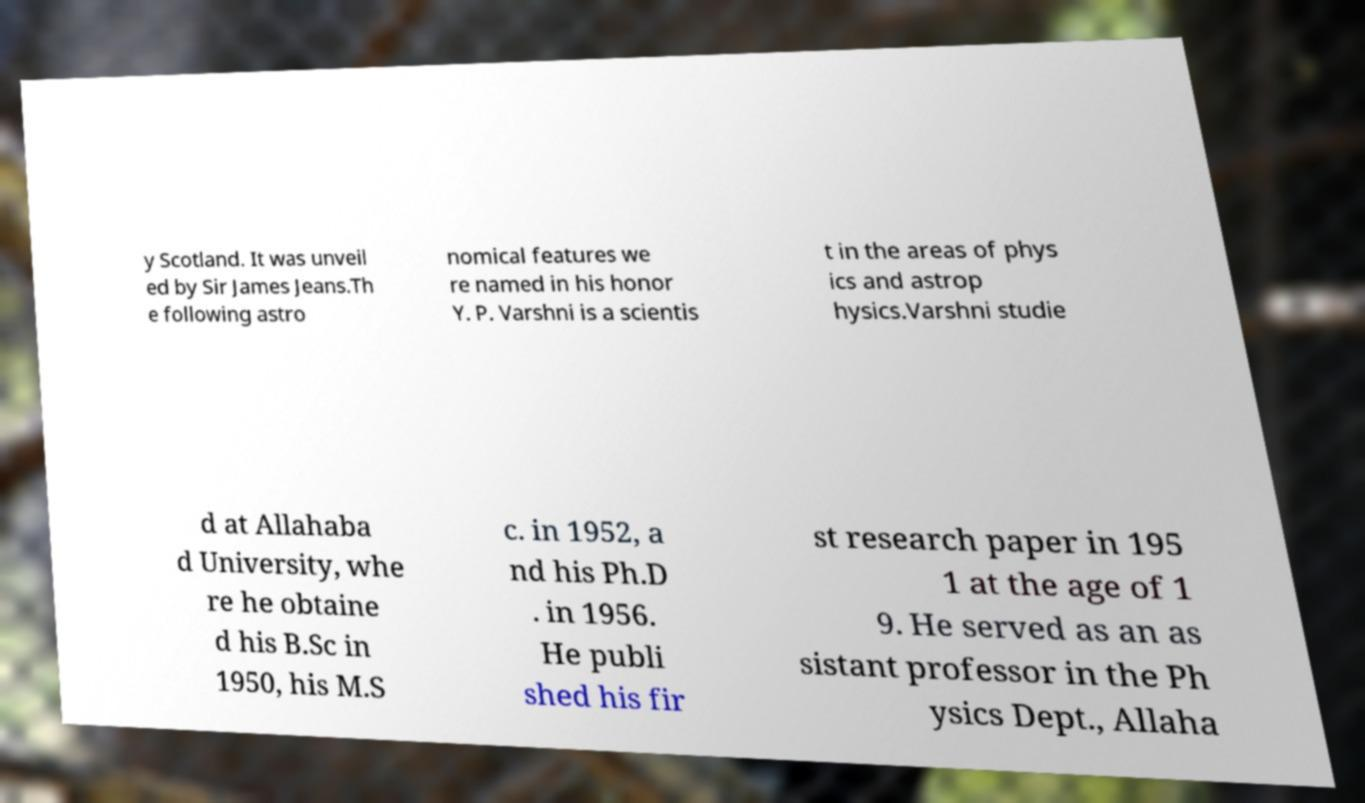For documentation purposes, I need the text within this image transcribed. Could you provide that? y Scotland. It was unveil ed by Sir James Jeans.Th e following astro nomical features we re named in his honor Y. P. Varshni is a scientis t in the areas of phys ics and astrop hysics.Varshni studie d at Allahaba d University, whe re he obtaine d his B.Sc in 1950, his M.S c. in 1952, a nd his Ph.D . in 1956. He publi shed his fir st research paper in 195 1 at the age of 1 9. He served as an as sistant professor in the Ph ysics Dept., Allaha 